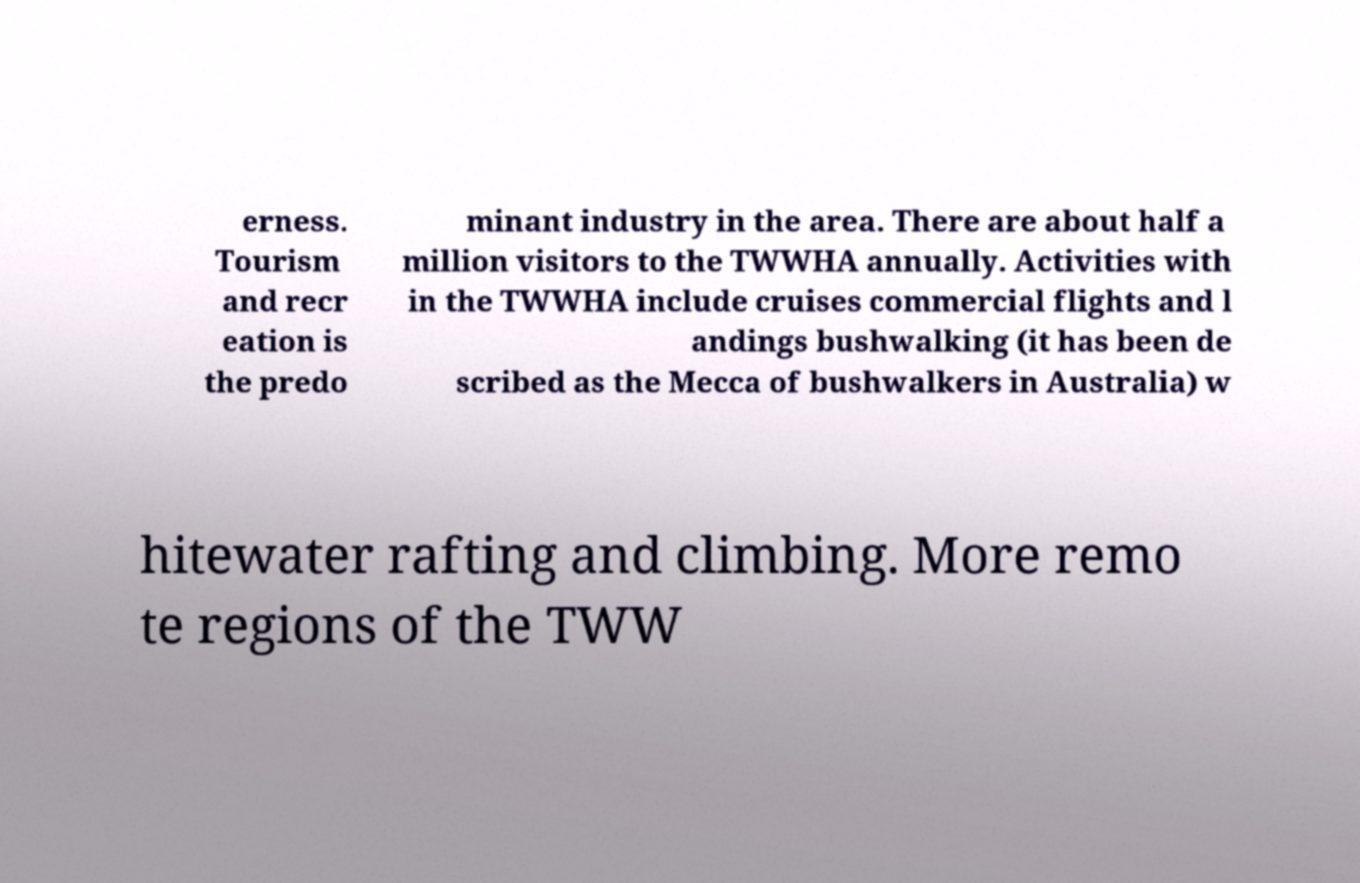There's text embedded in this image that I need extracted. Can you transcribe it verbatim? erness. Tourism and recr eation is the predo minant industry in the area. There are about half a million visitors to the TWWHA annually. Activities with in the TWWHA include cruises commercial flights and l andings bushwalking (it has been de scribed as the Mecca of bushwalkers in Australia) w hitewater rafting and climbing. More remo te regions of the TWW 